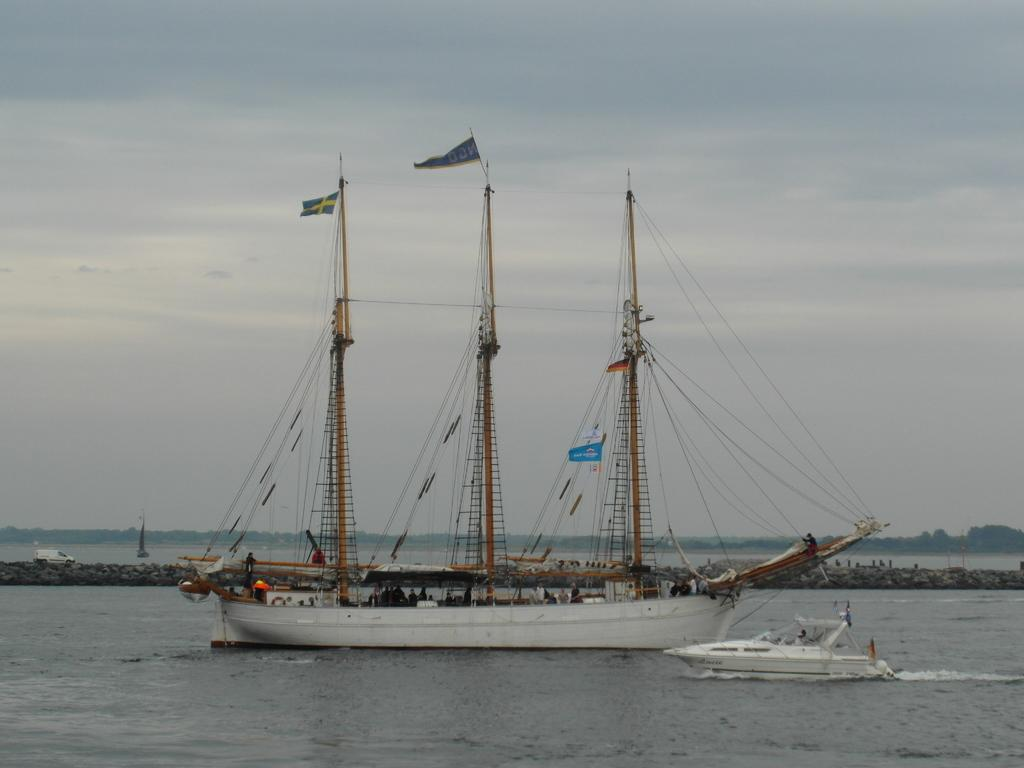What can be seen in the background of the image? There is a sky and trees visible in the background of the image. What types of watercraft are present in the image? There is a ship and a boat in the image. What structures can be seen in the image? There are poles and flags in the image. Who or what is present in the image? There are people and a vehicle in the image. What is the primary setting of the image? There is water visible in the image, suggesting a waterfront or maritime setting. What other objects can be seen in the image? There are other objects in the image, but their specific nature is not mentioned in the provided facts. What angle does the reason take in the image? There is no mention of an angle or reason in the image; the provided facts focus on the presence of various objects and subjects. 